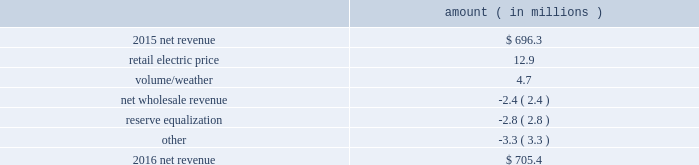2016 compared to 2015 net revenue consists of operating revenues net of : 1 ) fuel , fuel-related expenses , and gas purchased for resale , 2 ) purchased power expenses , and 3 ) other regulatory charges ( credits ) .
Following is an analysis of the change in net revenue comparing 2016 to 2015 .
Amount ( in millions ) .
The retail electric price variance is primarily due to a $ 19.4 million net annual increase in revenues , as approved by the mpsc , effective with the first billing cycle of july 2016 , and an increase in revenues collected through the storm damage rider . a0 see note 2 to the financial statements for more discussion of the formula rate plan and the storm damage rider .
The volume/weather variance is primarily due to an increase of 153 gwh , or 1% ( 1 % ) , in billed electricity usage , including an increase in industrial usage , partially offset by the effect of less favorable weather on residential and commercial sales .
The increase in industrial usage is primarily due to expansion projects in the pulp and paper industry , increased demand for existing customers , primarily in the metals industry , and new customers in the wood products industry .
The net wholesale revenue variance is primarily due to entergy mississippi 2019s exit from the system agreement in november 2015 .
The reserve equalization revenue variance is primarily due to the absence of reserve equalization revenue as compared to the same period in 2015 resulting from entergy mississippi 2019s exit from the system agreement in november other income statement variances 2017 compared to 2016 other operation and maintenance expenses decreased primarily due to : 2022 a decrease of $ 12 million in fossil-fueled generation expenses primarily due to lower long-term service agreement costs and a lower scope of work done during plant outages in 2017 as compared to the same period in 2016 ; and 2022 a decrease of $ 3.6 million in storm damage provisions .
See note 2 to the financial statements for a discussion on storm cost recovery .
The decrease was partially offset by an increase of $ 4.8 million in energy efficiency costs and an increase of $ 2.7 million in compensation and benefits costs primarily due to higher incentive-based compensation accruals in 2017 as compared to the prior year .
Entergy mississippi , inc .
Management 2019s financial discussion and analysis .
In 2016 what was the percentage change in net revenue? 
Computations: ((705.4 - 696.3) / 696.3)
Answer: 0.01307. 